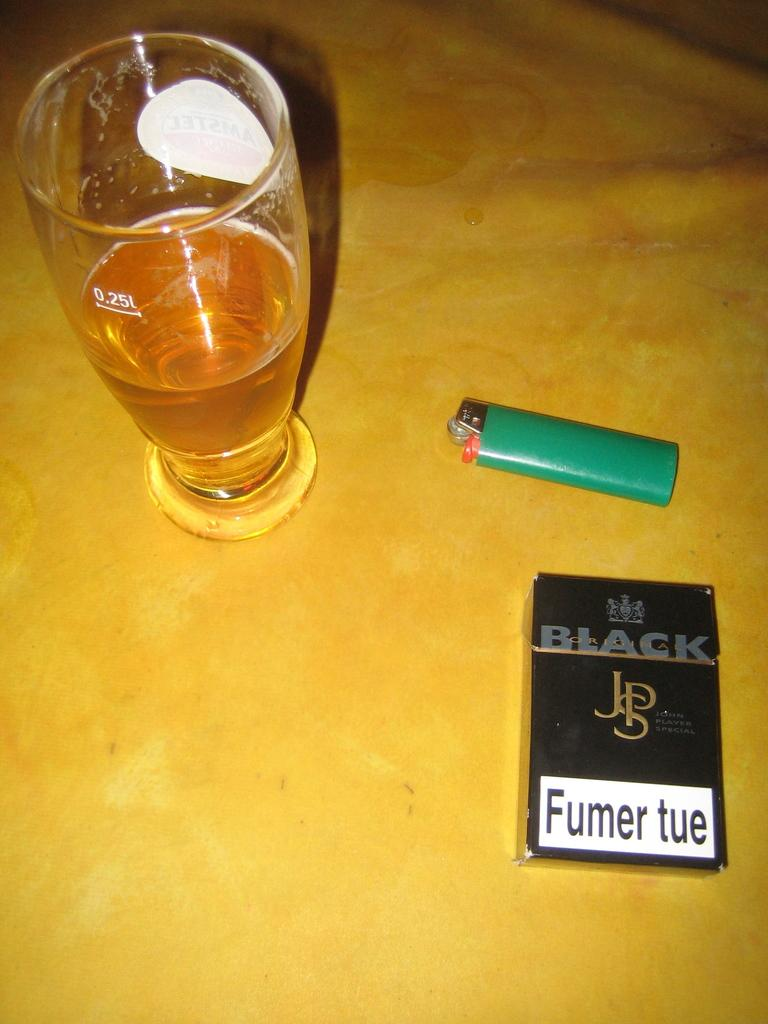Provide a one-sentence caption for the provided image. A pack of cigarettes has a white label that says Fumer tue on it. 